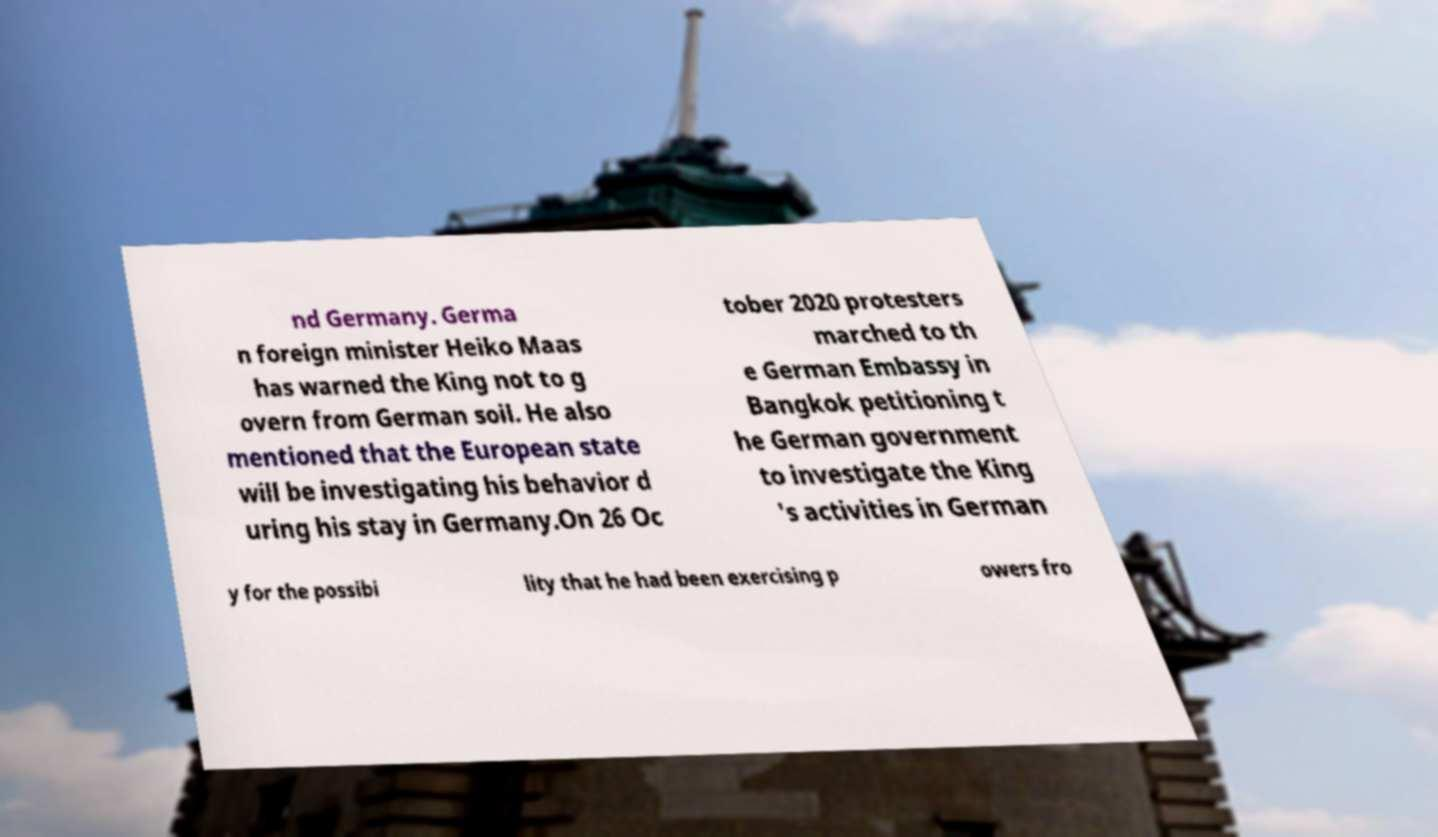I need the written content from this picture converted into text. Can you do that? nd Germany. Germa n foreign minister Heiko Maas has warned the King not to g overn from German soil. He also mentioned that the European state will be investigating his behavior d uring his stay in Germany.On 26 Oc tober 2020 protesters marched to th e German Embassy in Bangkok petitioning t he German government to investigate the King 's activities in German y for the possibi lity that he had been exercising p owers fro 